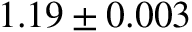Convert formula to latex. <formula><loc_0><loc_0><loc_500><loc_500>1 . 1 9 \pm 0 . 0 0 3</formula> 